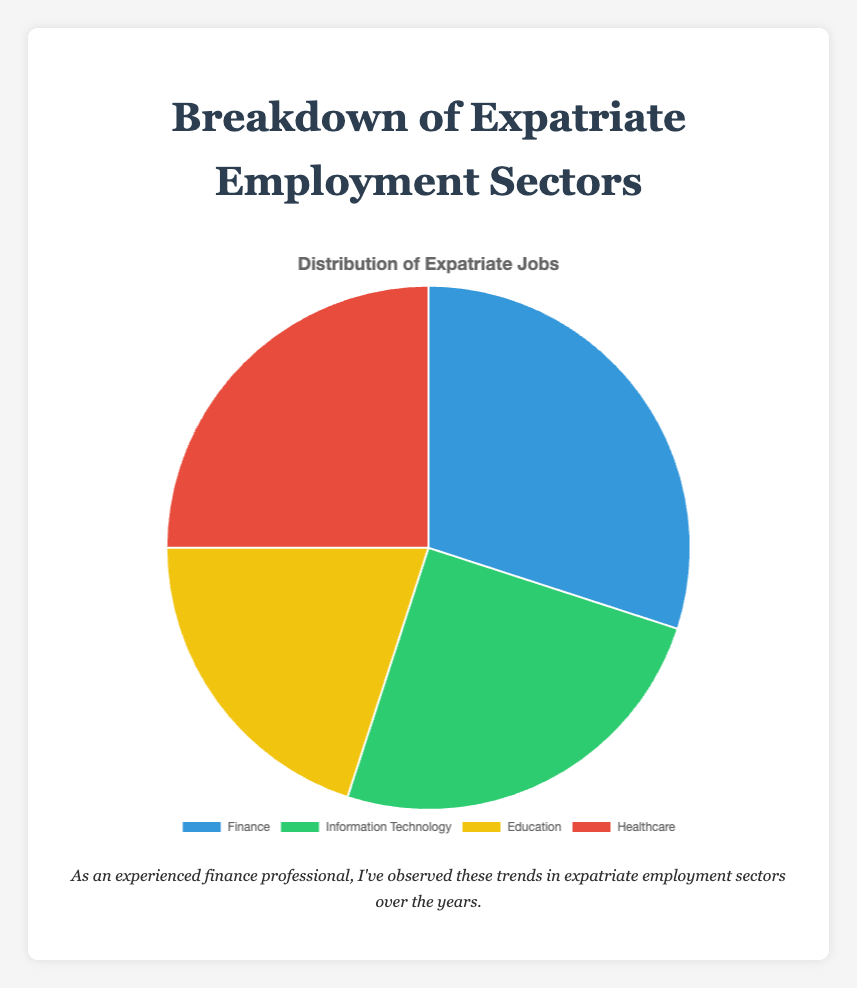Which sector has the highest percentage of expatriate employment? The pie chart shows that the 'Finance' sector has the largest percentage slice.
Answer: Finance What's the combined percentage of expatriates employed in Healthcare and IT? The Healthcare sector has 25%, and the IT sector also has 25%. Adding these two percentages together gives 25% + 25% = 50%.
Answer: 50% Which sectors have an equal percentage of expatriate employment? The 'Information Technology' and 'Healthcare' sectors both show a slice size representing 25% each.
Answer: Information Technology and Healthcare How much larger (in percentage points) is the expatriate employment in Finance compared to Education? The Finance sector is at 30%, while Education is at 20%. The difference is 30% - 20% = 10%.
Answer: 10% What percentage of expatriates does not work in Education? Education accounts for 20%. Subtracting this from 100% gives 100% - 20% = 80%.
Answer: 80% Which color is used to represent the Healthcare sector in the pie chart? The pie chart uses a red color to visually represent the Healthcare sector.
Answer: Red If you were to combine the expatriate percentages of the sectors other than Finance, what would their total be? Excluding Finance, the other sectors are Information Technology (25%), Education (20%), and Healthcare (25%). Their combined total is 25% + 20% + 25% = 70%.
Answer: 70% What is the average percentage of expatriate employment across all sectors represented? The percentages for the sectors are 30%, 25%, 20%, and 25%. Adding these up gives 100%, and there are 4 sectors. Therefore, the average is 100% / 4 = 25%.
Answer: 25% 